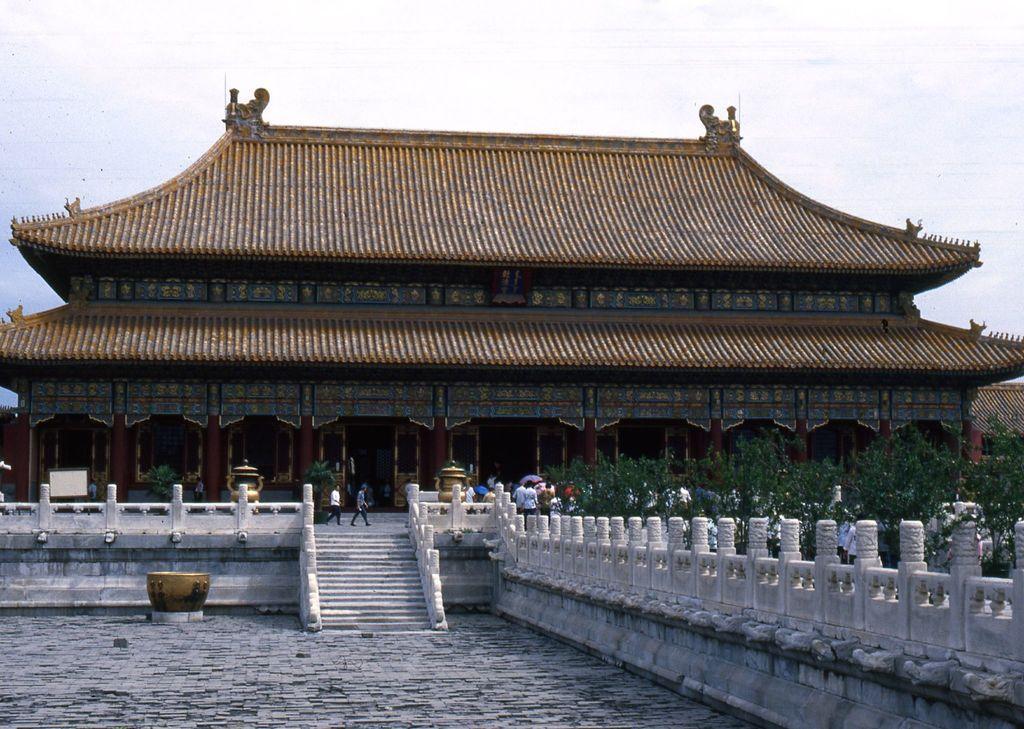In one or two sentences, can you explain what this image depicts? In this picture I can see the staircase in the middle and also there are few persons, on the right side there are trees. At the top there is a building, in the background there is the sky. 